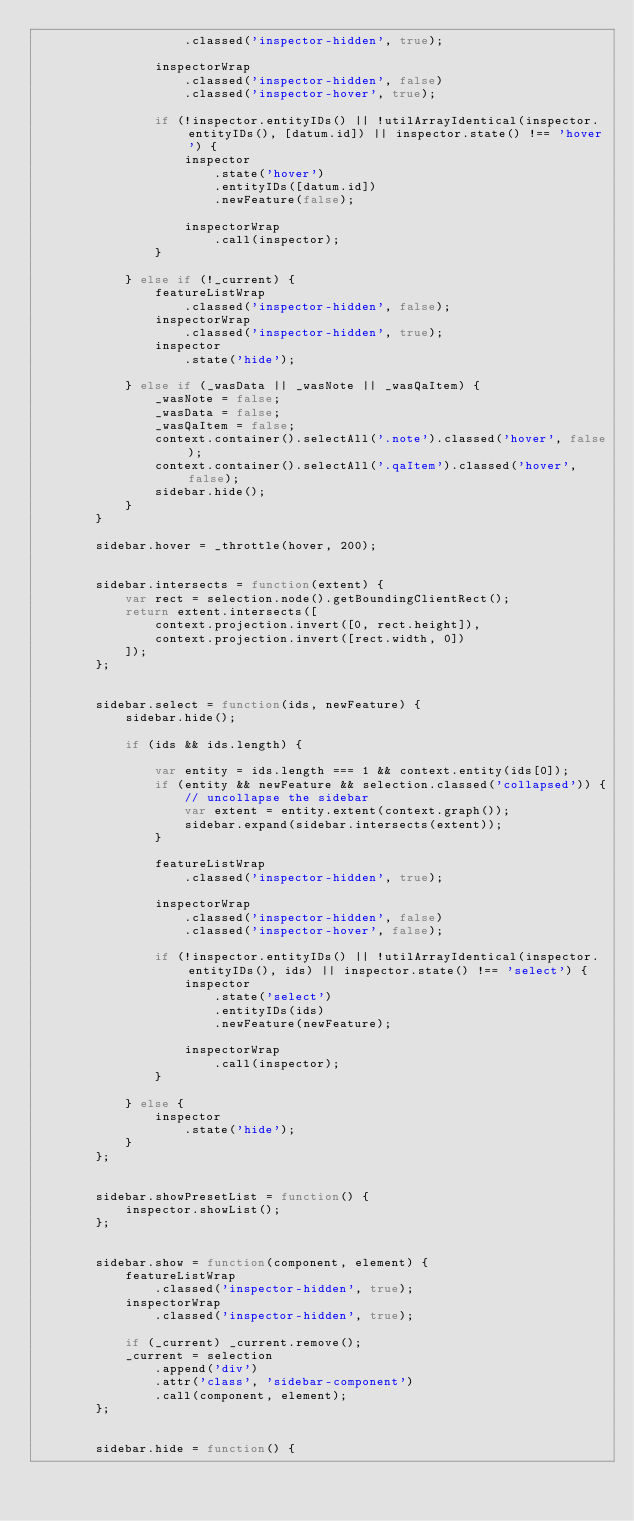Convert code to text. <code><loc_0><loc_0><loc_500><loc_500><_JavaScript_>                    .classed('inspector-hidden', true);

                inspectorWrap
                    .classed('inspector-hidden', false)
                    .classed('inspector-hover', true);

                if (!inspector.entityIDs() || !utilArrayIdentical(inspector.entityIDs(), [datum.id]) || inspector.state() !== 'hover') {
                    inspector
                        .state('hover')
                        .entityIDs([datum.id])
                        .newFeature(false);

                    inspectorWrap
                        .call(inspector);
                }

            } else if (!_current) {
                featureListWrap
                    .classed('inspector-hidden', false);
                inspectorWrap
                    .classed('inspector-hidden', true);
                inspector
                    .state('hide');

            } else if (_wasData || _wasNote || _wasQaItem) {
                _wasNote = false;
                _wasData = false;
                _wasQaItem = false;
                context.container().selectAll('.note').classed('hover', false);
                context.container().selectAll('.qaItem').classed('hover', false);
                sidebar.hide();
            }
        }

        sidebar.hover = _throttle(hover, 200);


        sidebar.intersects = function(extent) {
            var rect = selection.node().getBoundingClientRect();
            return extent.intersects([
                context.projection.invert([0, rect.height]),
                context.projection.invert([rect.width, 0])
            ]);
        };


        sidebar.select = function(ids, newFeature) {
            sidebar.hide();

            if (ids && ids.length) {

                var entity = ids.length === 1 && context.entity(ids[0]);
                if (entity && newFeature && selection.classed('collapsed')) {
                    // uncollapse the sidebar
                    var extent = entity.extent(context.graph());
                    sidebar.expand(sidebar.intersects(extent));
                }

                featureListWrap
                    .classed('inspector-hidden', true);

                inspectorWrap
                    .classed('inspector-hidden', false)
                    .classed('inspector-hover', false);

                if (!inspector.entityIDs() || !utilArrayIdentical(inspector.entityIDs(), ids) || inspector.state() !== 'select') {
                    inspector
                        .state('select')
                        .entityIDs(ids)
                        .newFeature(newFeature);

                    inspectorWrap
                        .call(inspector);
                }

            } else {
                inspector
                    .state('hide');
            }
        };


        sidebar.showPresetList = function() {
            inspector.showList();
        };


        sidebar.show = function(component, element) {
            featureListWrap
                .classed('inspector-hidden', true);
            inspectorWrap
                .classed('inspector-hidden', true);

            if (_current) _current.remove();
            _current = selection
                .append('div')
                .attr('class', 'sidebar-component')
                .call(component, element);
        };


        sidebar.hide = function() {</code> 